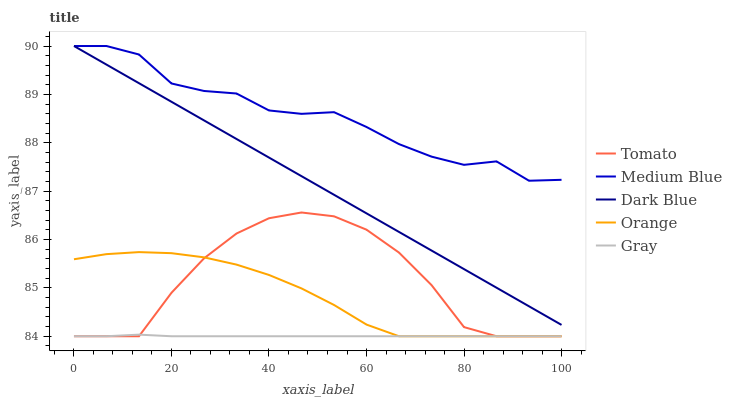Does Gray have the minimum area under the curve?
Answer yes or no. Yes. Does Medium Blue have the maximum area under the curve?
Answer yes or no. Yes. Does Dark Blue have the minimum area under the curve?
Answer yes or no. No. Does Dark Blue have the maximum area under the curve?
Answer yes or no. No. Is Dark Blue the smoothest?
Answer yes or no. Yes. Is Tomato the roughest?
Answer yes or no. Yes. Is Orange the smoothest?
Answer yes or no. No. Is Orange the roughest?
Answer yes or no. No. Does Dark Blue have the lowest value?
Answer yes or no. No. Does Orange have the highest value?
Answer yes or no. No. Is Gray less than Medium Blue?
Answer yes or no. Yes. Is Dark Blue greater than Gray?
Answer yes or no. Yes. Does Gray intersect Medium Blue?
Answer yes or no. No. 